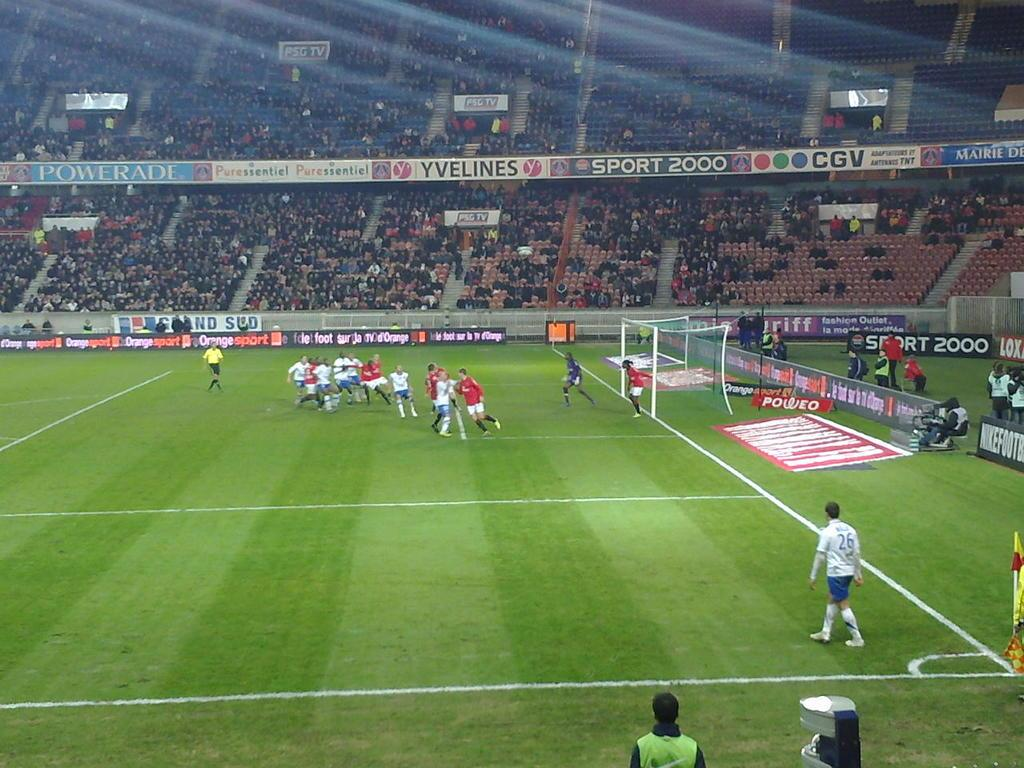<image>
Create a compact narrative representing the image presented. A soccer stadium with varied ads from companies like Orange Sport displayed on the stands is hosting a game. 